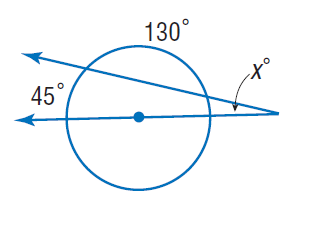Answer the mathemtical geometry problem and directly provide the correct option letter.
Question: Find x.
Choices: A: 20 B: 45 C: 65 D: 130 A 